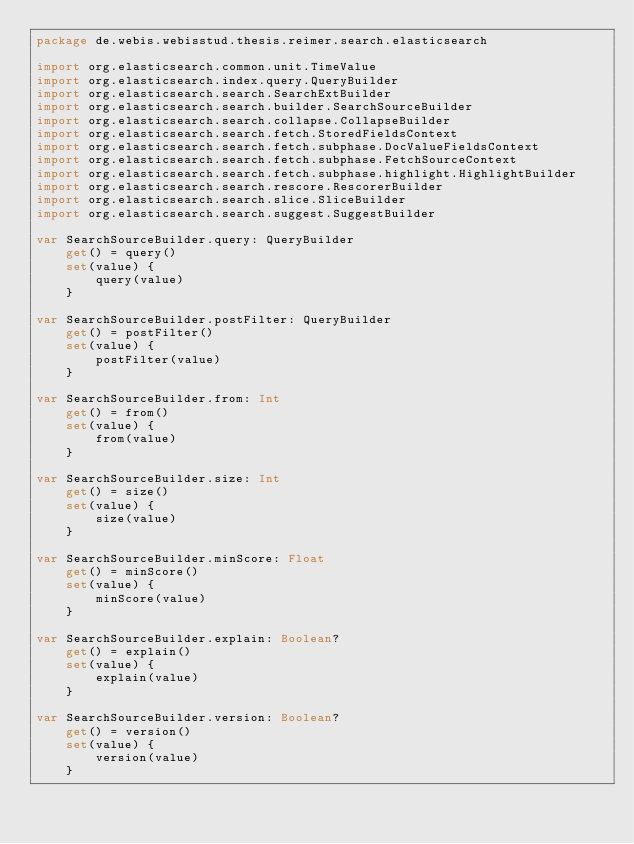Convert code to text. <code><loc_0><loc_0><loc_500><loc_500><_Kotlin_>package de.webis.webisstud.thesis.reimer.search.elasticsearch

import org.elasticsearch.common.unit.TimeValue
import org.elasticsearch.index.query.QueryBuilder
import org.elasticsearch.search.SearchExtBuilder
import org.elasticsearch.search.builder.SearchSourceBuilder
import org.elasticsearch.search.collapse.CollapseBuilder
import org.elasticsearch.search.fetch.StoredFieldsContext
import org.elasticsearch.search.fetch.subphase.DocValueFieldsContext
import org.elasticsearch.search.fetch.subphase.FetchSourceContext
import org.elasticsearch.search.fetch.subphase.highlight.HighlightBuilder
import org.elasticsearch.search.rescore.RescorerBuilder
import org.elasticsearch.search.slice.SliceBuilder
import org.elasticsearch.search.suggest.SuggestBuilder

var SearchSourceBuilder.query: QueryBuilder
    get() = query()
    set(value) {
        query(value)
    }

var SearchSourceBuilder.postFilter: QueryBuilder
    get() = postFilter()
    set(value) {
        postFilter(value)
    }

var SearchSourceBuilder.from: Int
    get() = from()
    set(value) {
        from(value)
    }

var SearchSourceBuilder.size: Int
    get() = size()
    set(value) {
        size(value)
    }

var SearchSourceBuilder.minScore: Float
    get() = minScore()
    set(value) {
        minScore(value)
    }

var SearchSourceBuilder.explain: Boolean?
    get() = explain()
    set(value) {
        explain(value)
    }

var SearchSourceBuilder.version: Boolean?
    get() = version()
    set(value) {
        version(value)
    }
</code> 